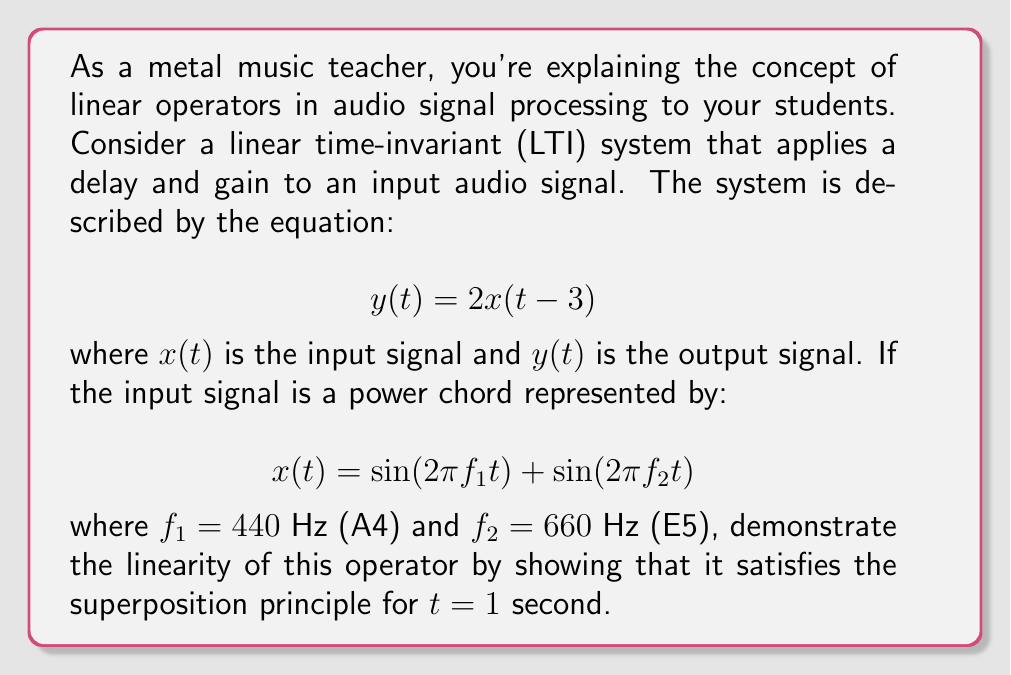Could you help me with this problem? Let's approach this step-by-step:

1) The superposition principle states that for a linear operator $L$:
   $$L(ax_1 + bx_2) = aL(x_1) + bL(x_2)$$
   where $a$ and $b$ are scalars, and $x_1$ and $x_2$ are input signals.

2) In our case, $L$ is the operator that applies the delay and gain:
   $$L[x(t)] = 2x(t-3)$$

3) We need to show that:
   $$L[\sin(2\pi f_1 t) + \sin(2\pi f_2 t)] = L[\sin(2\pi f_1 t)] + L[\sin(2\pi f_2 t)]$$

4) Let's apply $L$ to the left side:
   $$L[\sin(2\pi f_1 t) + \sin(2\pi f_2 t)] = 2[\sin(2\pi f_1 (t-3)) + \sin(2\pi f_2 (t-3))]$$

5) Now, let's apply $L$ to each term on the right side:
   $$L[\sin(2\pi f_1 t)] + L[\sin(2\pi f_2 t)] = 2\sin(2\pi f_1 (t-3)) + 2\sin(2\pi f_2 (t-3))$$

6) We can see that the results are identical, demonstrating linearity.

7) To complete the problem, let's evaluate both sides at $t=1$:
   
   Left side:
   $$2[\sin(2\pi \cdot 440 \cdot (1-3)) + \sin(2\pi \cdot 660 \cdot (1-3))]$$
   $$= 2[\sin(-4400\pi) + \sin(-6600\pi)] = 0$$

   Right side:
   $$2\sin(2\pi \cdot 440 \cdot (1-3)) + 2\sin(2\pi \cdot 660 \cdot (1-3))$$
   $$= 2\sin(-4400\pi) + 2\sin(-6600\pi) = 0$$

Both sides evaluate to 0, confirming the linearity of the operator for this specific input at $t=1$.
Answer: 0 